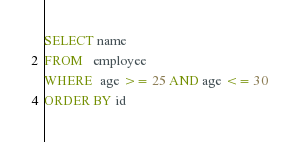Convert code to text. <code><loc_0><loc_0><loc_500><loc_500><_SQL_>SELECT name
FROM   employee
WHERE  age >= 25 AND age <= 30
ORDER BY id 
</code> 